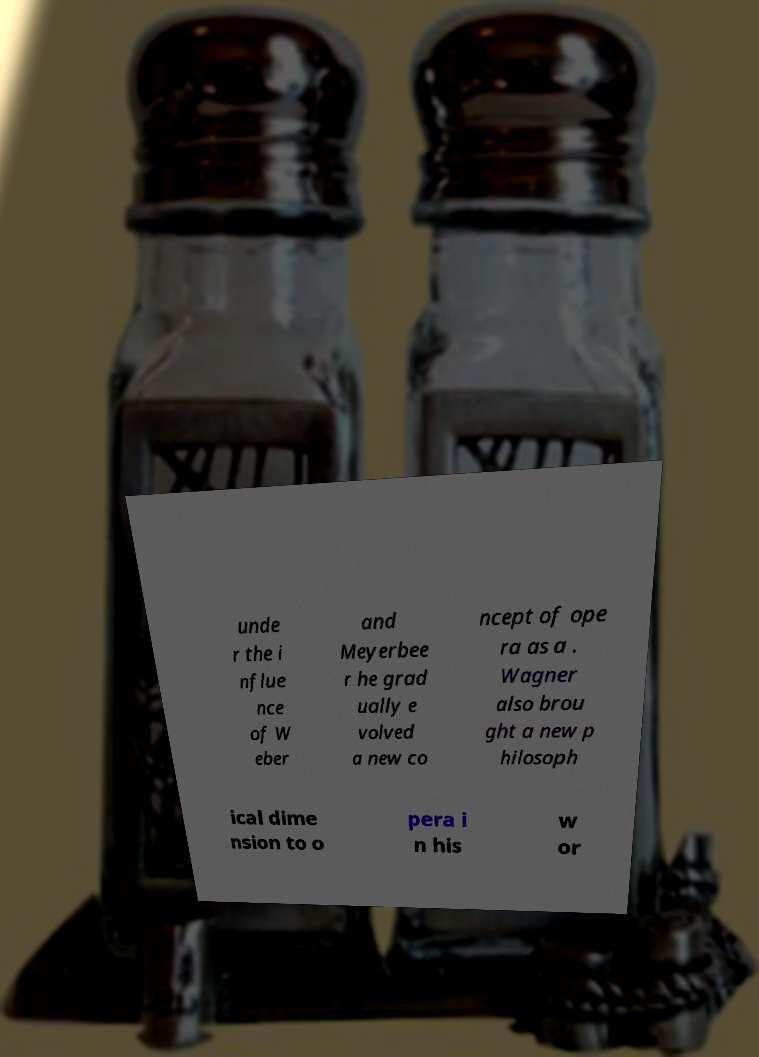Can you accurately transcribe the text from the provided image for me? unde r the i nflue nce of W eber and Meyerbee r he grad ually e volved a new co ncept of ope ra as a . Wagner also brou ght a new p hilosoph ical dime nsion to o pera i n his w or 